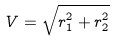<formula> <loc_0><loc_0><loc_500><loc_500>V = \sqrt { r _ { 1 } ^ { 2 } + r _ { 2 } ^ { 2 } }</formula> 